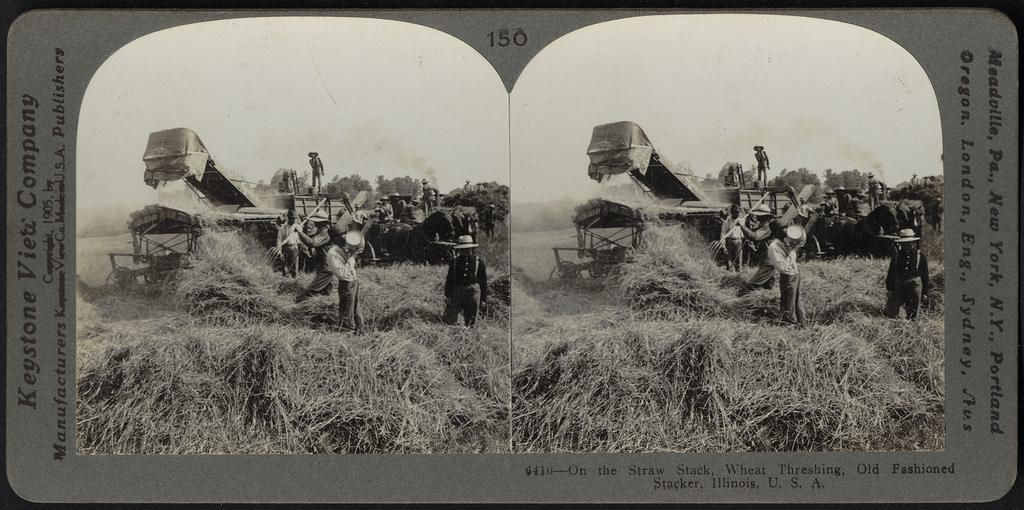<image>
Provide a brief description of the given image. Picture of an old farm with the number 150 in the middle top 